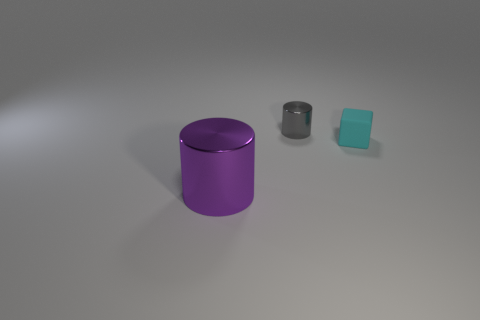Are there any other objects near the large cylinder? Yes, beside the large purple cylinder, there is a smaller, metallic grey cylinder and an even smaller teal cube, all placed on a flat surface. 